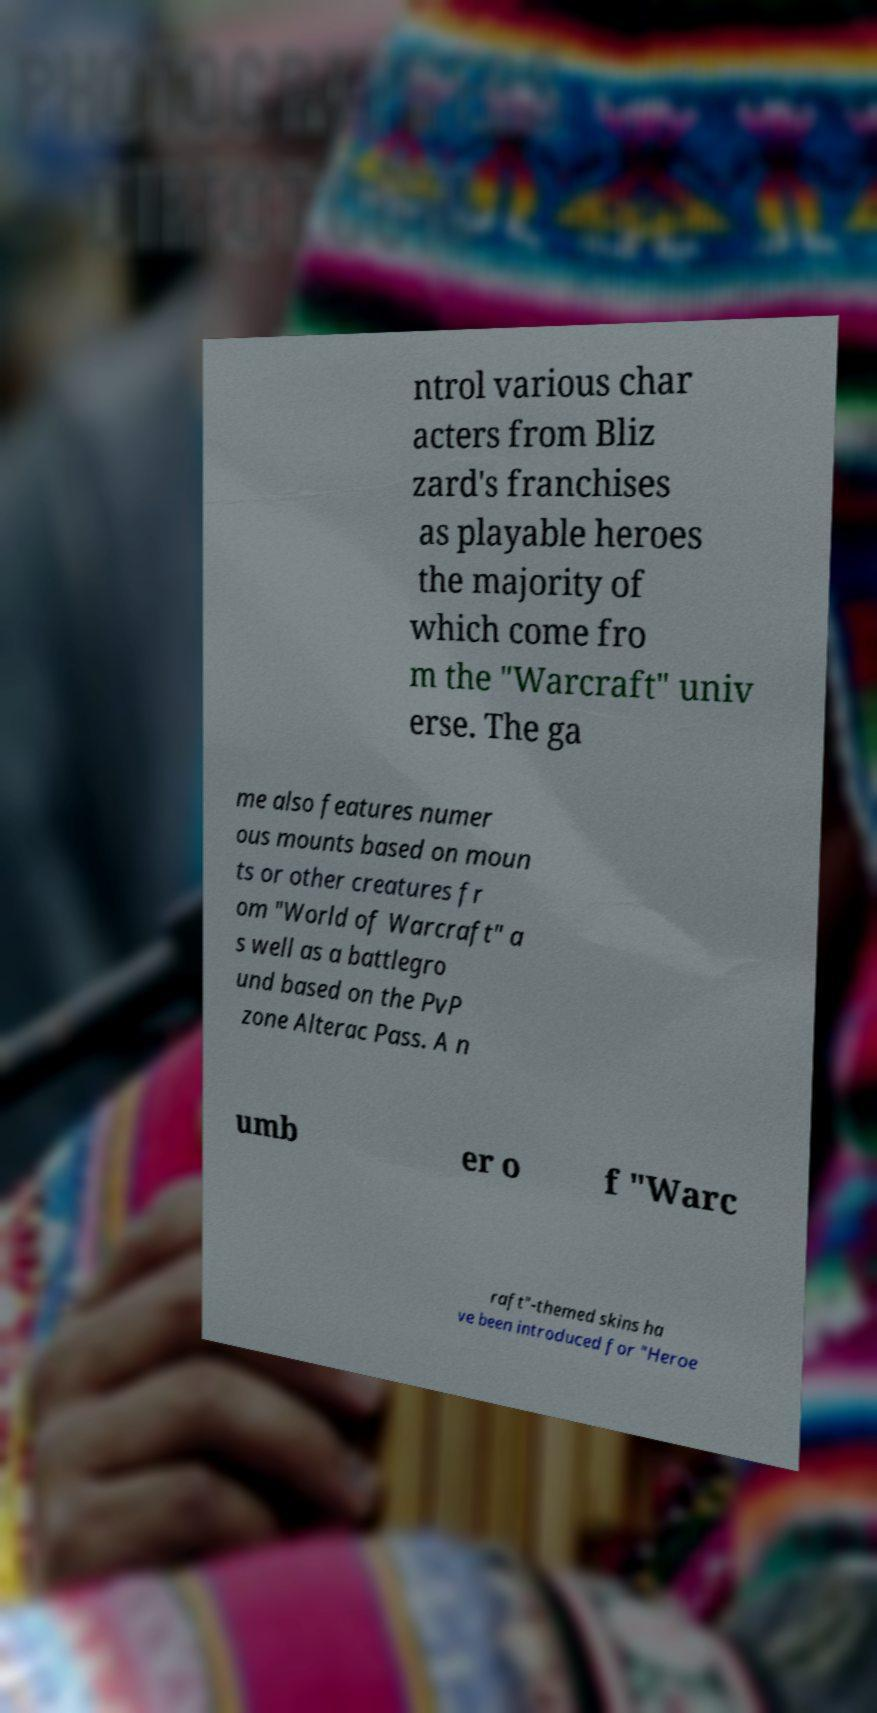Can you read and provide the text displayed in the image?This photo seems to have some interesting text. Can you extract and type it out for me? ntrol various char acters from Bliz zard's franchises as playable heroes the majority of which come fro m the "Warcraft" univ erse. The ga me also features numer ous mounts based on moun ts or other creatures fr om "World of Warcraft" a s well as a battlegro und based on the PvP zone Alterac Pass. A n umb er o f "Warc raft"-themed skins ha ve been introduced for "Heroe 